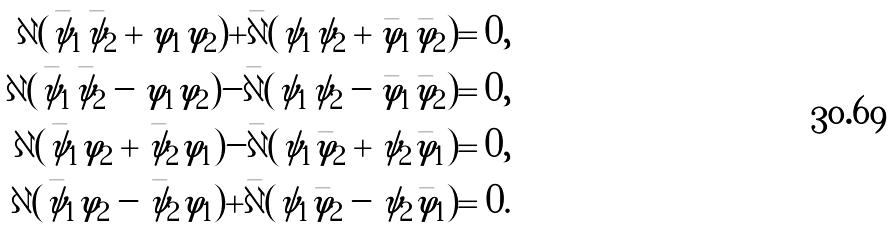<formula> <loc_0><loc_0><loc_500><loc_500>\partial ( \bar { \psi } _ { 1 } \bar { \psi } _ { 2 } + \varphi _ { 1 } \varphi _ { 2 } ) + \bar { \partial } ( \psi _ { 1 } \psi _ { 2 } + \bar { \varphi } _ { 1 } \bar { \varphi } _ { 2 } ) = 0 , \\ \partial ( \bar { \psi } _ { 1 } \bar { \psi } _ { 2 } - \varphi _ { 1 } \varphi _ { 2 } ) - \bar { \partial } ( \psi _ { 1 } \psi _ { 2 } - \bar { \varphi } _ { 1 } \bar { \varphi } _ { 2 } ) = 0 , \\ \partial ( \bar { \psi } _ { 1 } \varphi _ { 2 } + \bar { \psi } _ { 2 } \varphi _ { 1 } ) - \bar { \partial } ( \psi _ { 1 } \bar { \varphi } _ { 2 } + \psi _ { 2 } \bar { \varphi } _ { 1 } ) = 0 , \\ \partial ( \bar { \psi } _ { 1 } \varphi _ { 2 } - \bar { \psi } _ { 2 } \varphi _ { 1 } ) + \bar { \partial } ( \psi _ { 1 } \bar { \varphi } _ { 2 } - \psi _ { 2 } \bar { \varphi } _ { 1 } ) = 0 .</formula> 